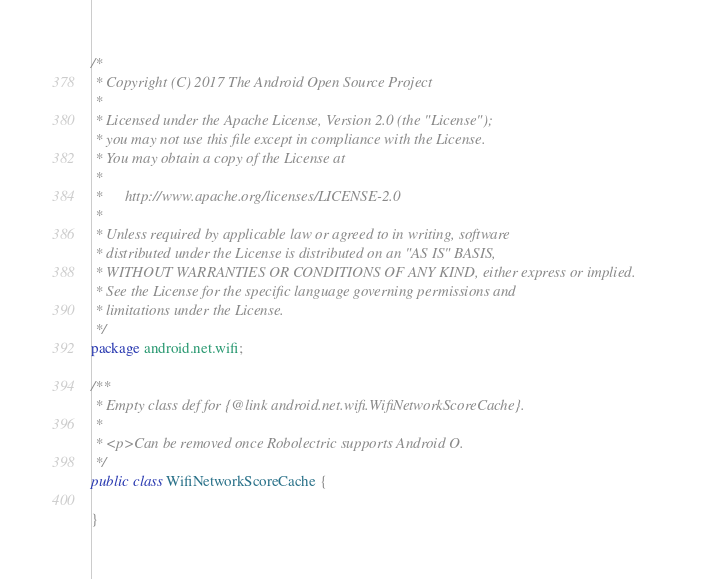<code> <loc_0><loc_0><loc_500><loc_500><_Java_>/*
 * Copyright (C) 2017 The Android Open Source Project
 *
 * Licensed under the Apache License, Version 2.0 (the "License");
 * you may not use this file except in compliance with the License.
 * You may obtain a copy of the License at
 *
 *      http://www.apache.org/licenses/LICENSE-2.0
 *
 * Unless required by applicable law or agreed to in writing, software
 * distributed under the License is distributed on an "AS IS" BASIS,
 * WITHOUT WARRANTIES OR CONDITIONS OF ANY KIND, either express or implied.
 * See the License for the specific language governing permissions and
 * limitations under the License.
 */
package android.net.wifi;

/**
 * Empty class def for {@link android.net.wifi.WifiNetworkScoreCache}.
 *
 * <p>Can be removed once Robolectric supports Android O.
 */
public class WifiNetworkScoreCache {

}
</code> 